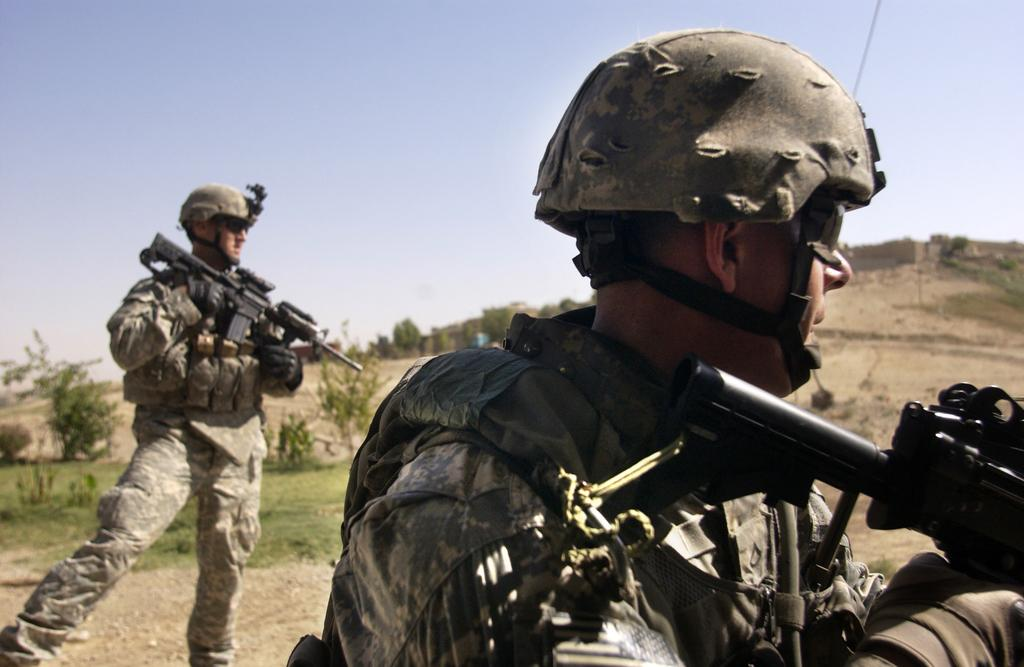How many people are in the image? There are two people in the image. What are the people wearing? The people are wearing military uniforms. What are the people holding in the image? The people are holding weapons. What can be seen in the background of the image? There are plants, trees, and the sky visible in the background of the image. What type of ornament is hanging from the tree in the image? There is no ornament hanging from the tree in the image; only plants, trees, and the sky are visible in the background. 